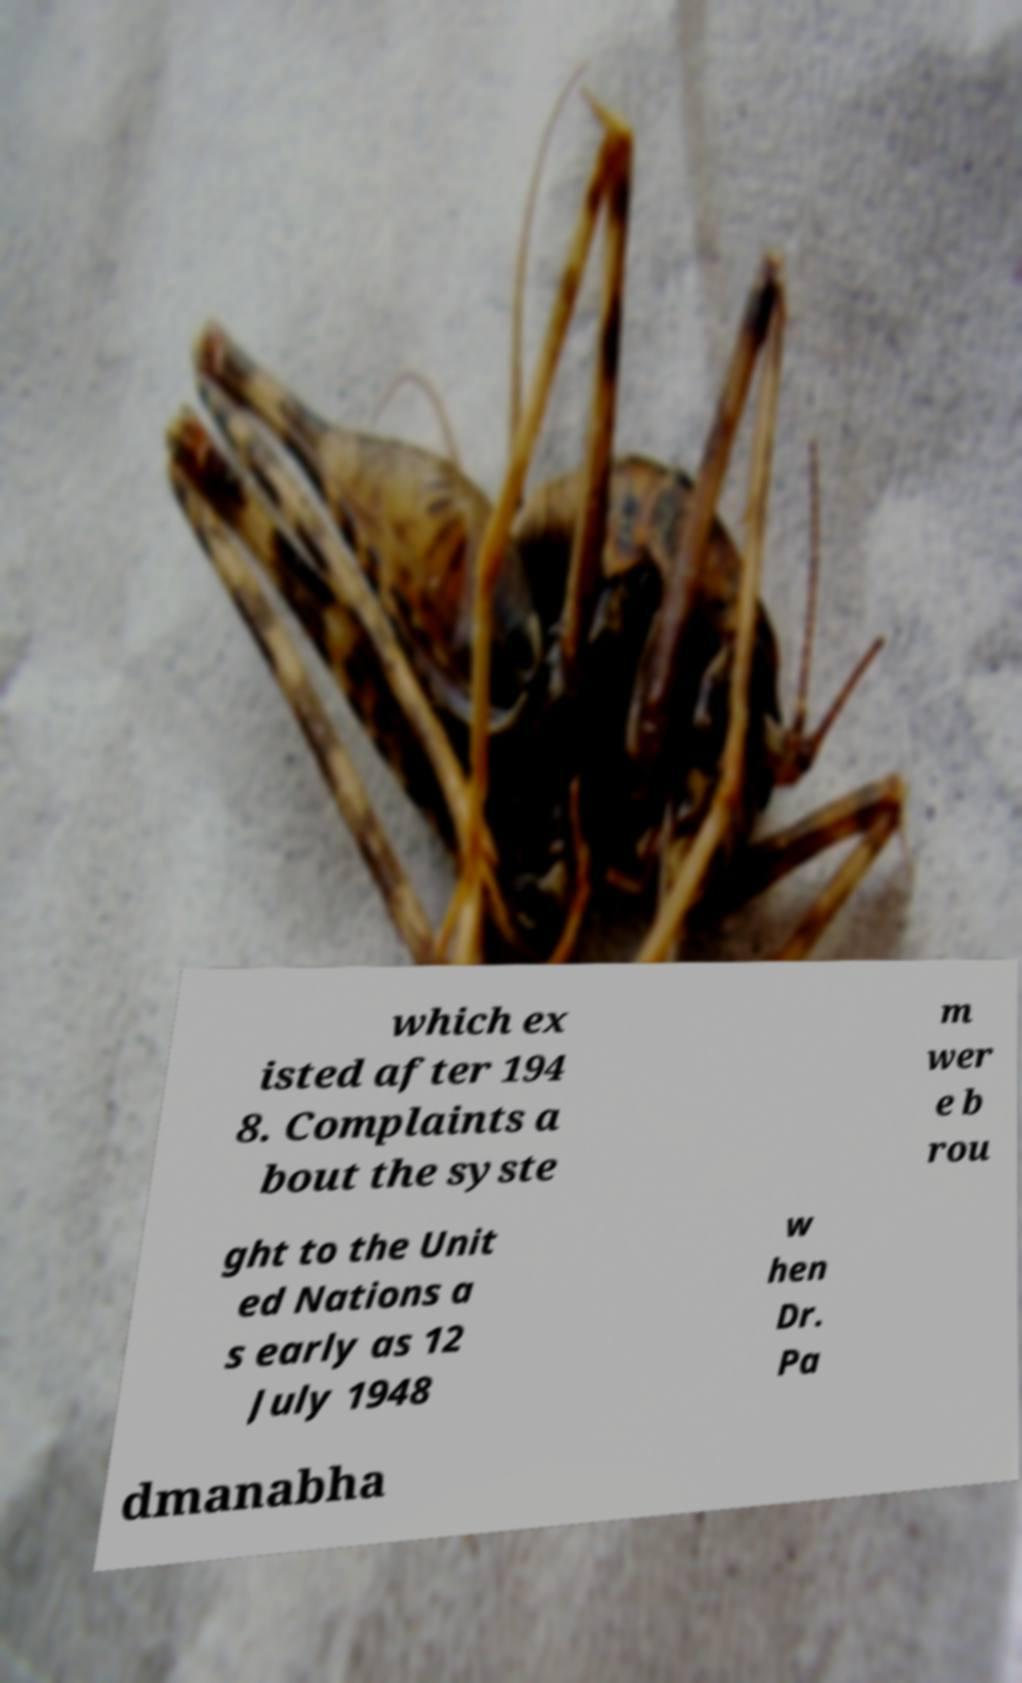Please identify and transcribe the text found in this image. which ex isted after 194 8. Complaints a bout the syste m wer e b rou ght to the Unit ed Nations a s early as 12 July 1948 w hen Dr. Pa dmanabha 